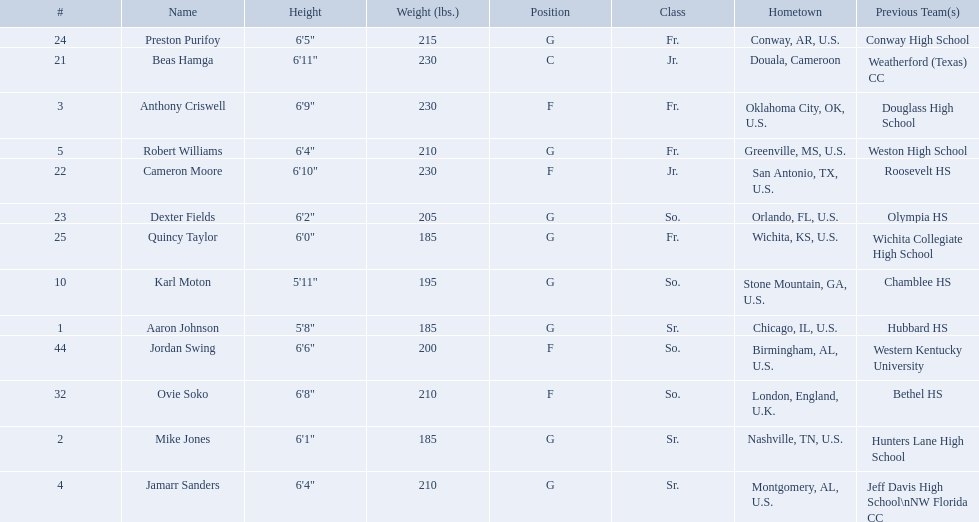Who are all the players? Aaron Johnson, Anthony Criswell, Jamarr Sanders, Robert Williams, Karl Moton, Beas Hamga, Cameron Moore, Dexter Fields, Preston Purifoy, Ovie Soko, Mike Jones, Quincy Taylor, Jordan Swing. Of these, which are not soko? Aaron Johnson, Anthony Criswell, Jamarr Sanders, Robert Williams, Karl Moton, Beas Hamga, Cameron Moore, Dexter Fields, Preston Purifoy, Mike Jones, Quincy Taylor, Jordan Swing. Where are these players from? Sr., Fr., Sr., Fr., So., Jr., Jr., So., Fr., Sr., Fr., So. Of these locations, which are not in the u.s.? Jr. Which player is from this location? Beas Hamga. 